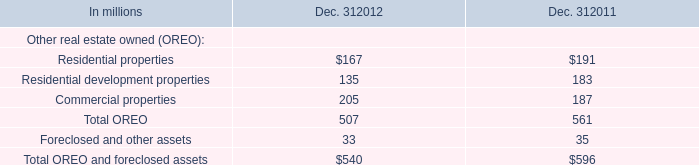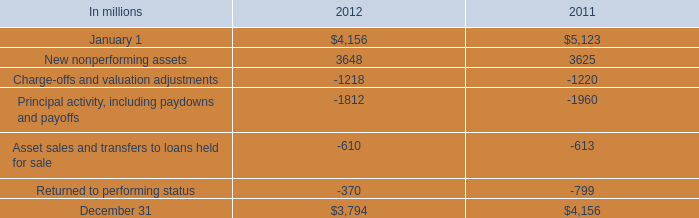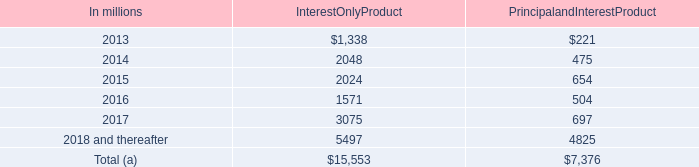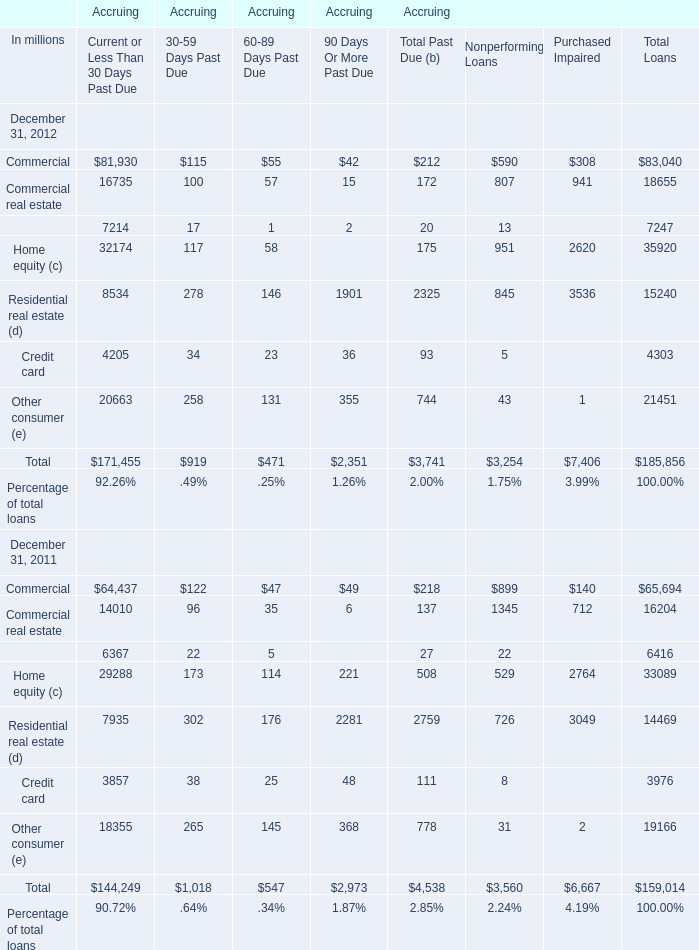What was the average value of Commercial real estateEquipment lease financing Home equity in Current or Less Than 30 Days Past Due (in million) 
Computations: (((16735 + 7214) + 32174) / 3)
Answer: 18707.66667. 